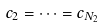Convert formula to latex. <formula><loc_0><loc_0><loc_500><loc_500>c _ { 2 } = \dots = c _ { N _ { 2 } }</formula> 